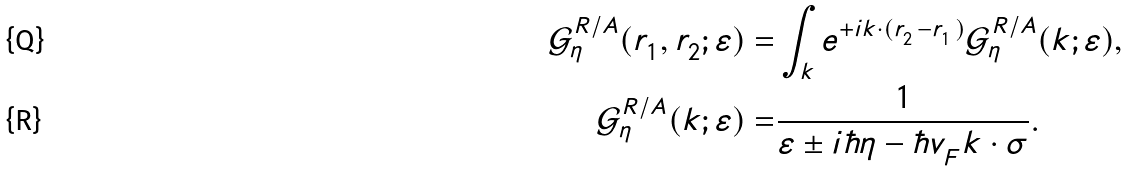<formula> <loc_0><loc_0><loc_500><loc_500>\mathcal { G } ^ { R / A } _ { \eta } ( r ^ { \ } _ { 1 } , r ^ { \ } _ { 2 } ; \varepsilon ) = & \int _ { k } e ^ { + { i } k \cdot ( r ^ { \ } _ { 2 } - r ^ { \ } _ { 1 } ) } \mathcal { G } ^ { R / A } _ { \eta } ( k ; \varepsilon ) , \\ \mathcal { G } ^ { R / A } _ { \eta } ( k ; \varepsilon ) = & \frac { 1 } { \varepsilon \pm { i } \hbar { \eta } - \hbar { v } ^ { \ } _ { F } k \cdot \sigma } .</formula> 